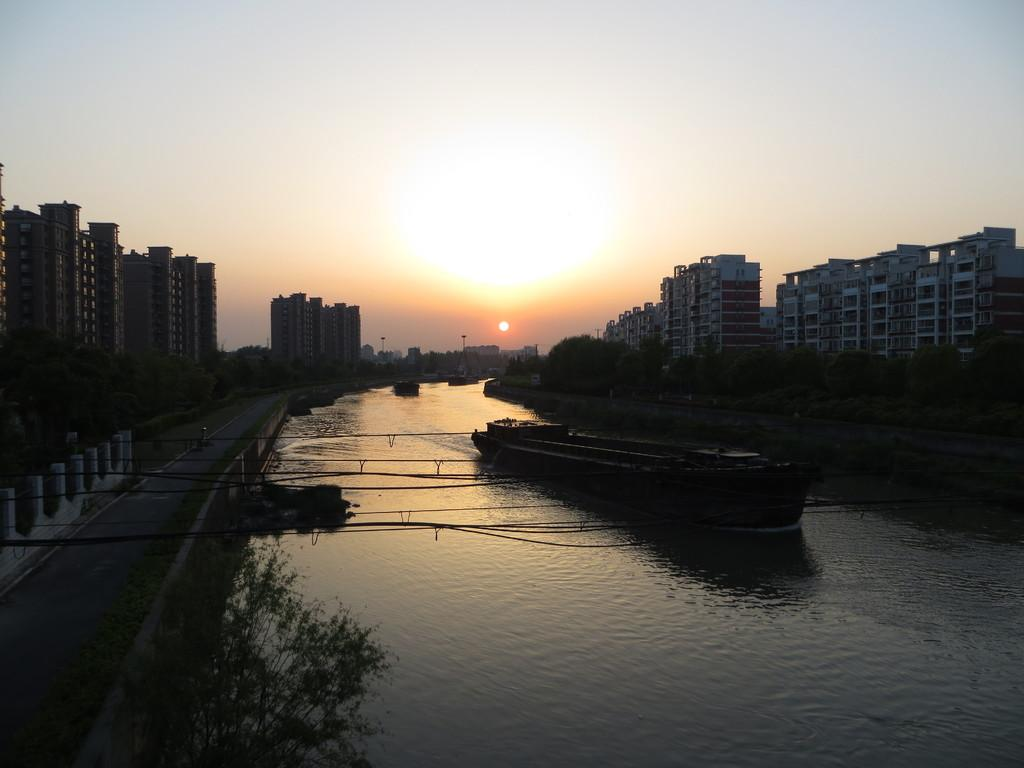What type of structures can be seen in the image? There are buildings with windows in the image. What type of vegetation is present in the image? There are trees and plants in the image. What mode of transportation is visible in the image? There is a boat in the image. What natural element is visible in the image? Water is visible in the image. What part of the environment can be seen in the image? The sky is visible in the image. Can you tell me how many bananas are hanging from the trees in the image? There are no bananas present in the image; it features trees without any fruit. What type of request is being made in the image? There is no request being made in the image; it is a scene with buildings, trees, plants, a boat, water, and the sky. 